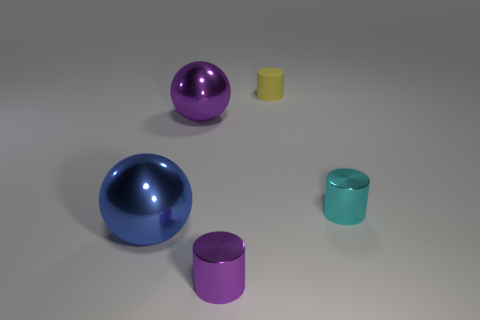The large metal sphere that is in front of the small metallic cylinder behind the tiny purple metal cylinder on the left side of the tiny rubber cylinder is what color?
Ensure brevity in your answer.  Blue. There is another thing that is the same shape as the blue thing; what color is it?
Make the answer very short. Purple. Are there the same number of metal objects behind the small cyan cylinder and small metal cylinders?
Make the answer very short. No. How many spheres are either cyan matte objects or cyan things?
Keep it short and to the point. 0. There is a ball that is made of the same material as the blue object; what is its color?
Give a very brief answer. Purple. Are the tiny purple cylinder and the large ball to the left of the big purple metal ball made of the same material?
Offer a terse response. Yes. How many things are tiny metal objects or cyan shiny objects?
Give a very brief answer. 2. Is there a tiny yellow object that has the same shape as the tiny cyan object?
Give a very brief answer. Yes. There is a cyan thing; how many purple metal spheres are in front of it?
Your response must be concise. 0. There is a purple thing to the left of the tiny object that is in front of the large blue sphere; what is it made of?
Provide a succinct answer. Metal. 